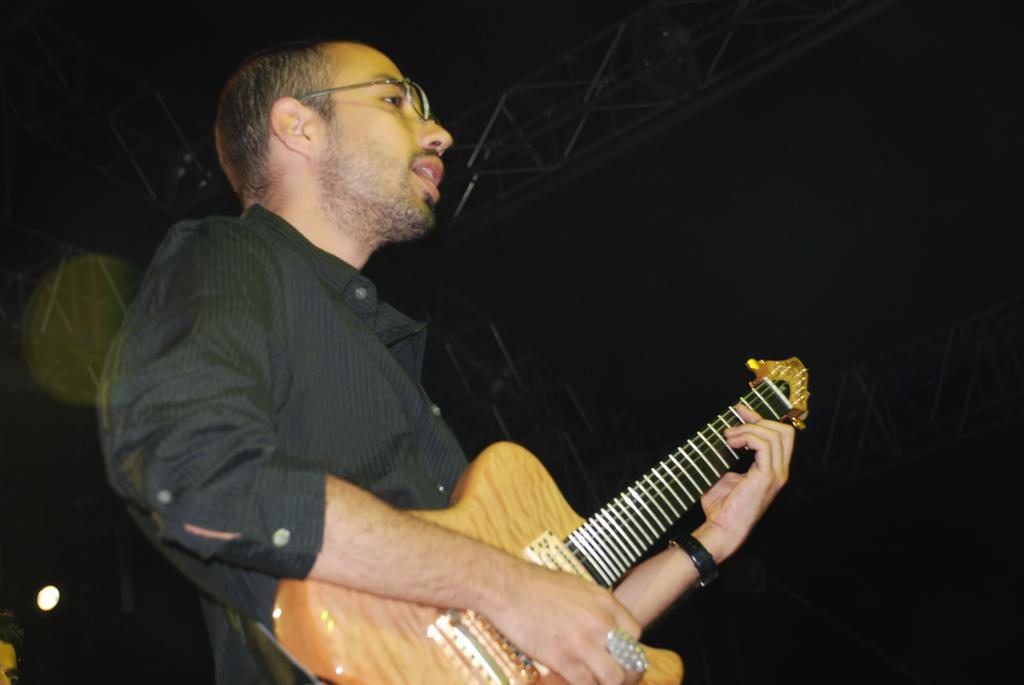Can you describe this image briefly? There is a man who is playing guitar. He has spectacles and this is light. 